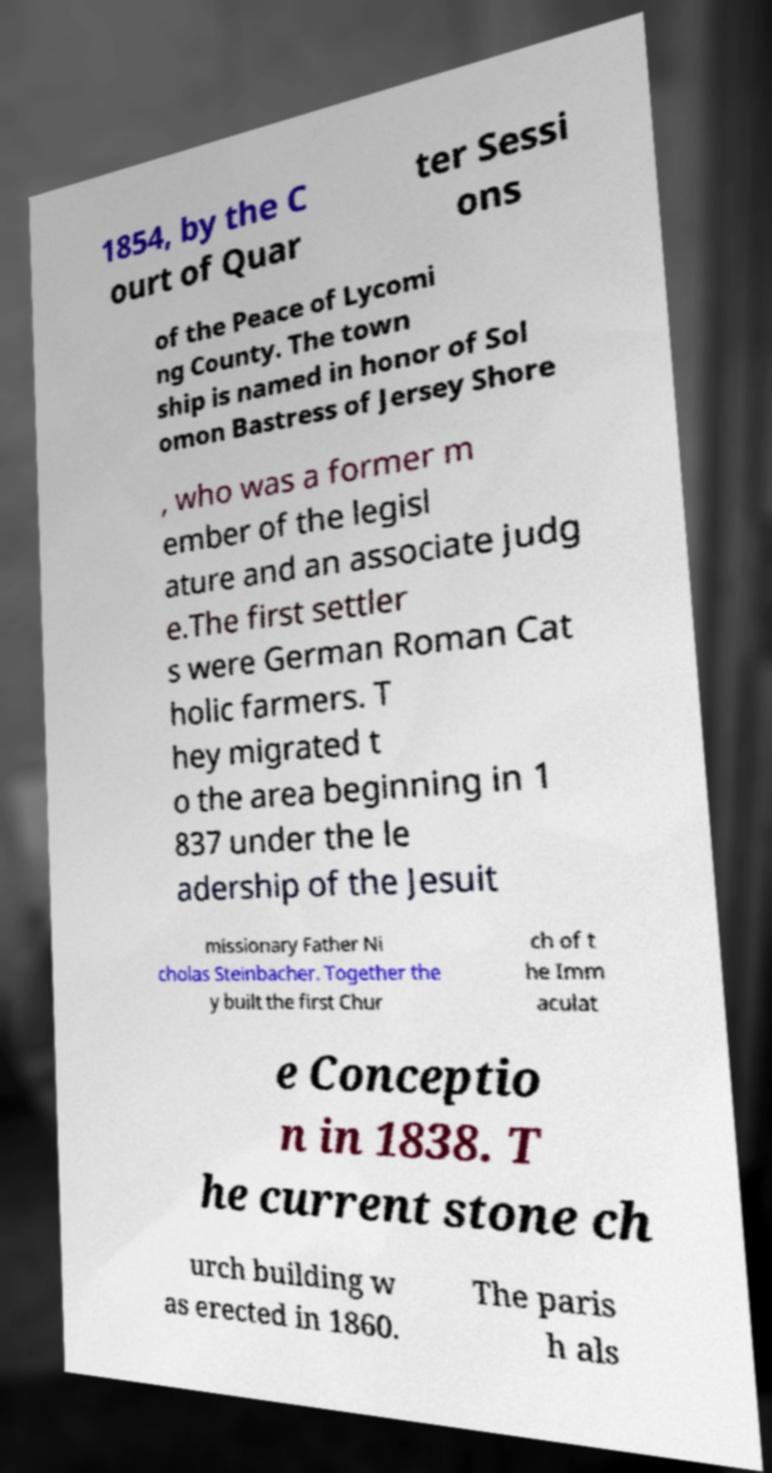Could you extract and type out the text from this image? 1854, by the C ourt of Quar ter Sessi ons of the Peace of Lycomi ng County. The town ship is named in honor of Sol omon Bastress of Jersey Shore , who was a former m ember of the legisl ature and an associate judg e.The first settler s were German Roman Cat holic farmers. T hey migrated t o the area beginning in 1 837 under the le adership of the Jesuit missionary Father Ni cholas Steinbacher. Together the y built the first Chur ch of t he Imm aculat e Conceptio n in 1838. T he current stone ch urch building w as erected in 1860. The paris h als 